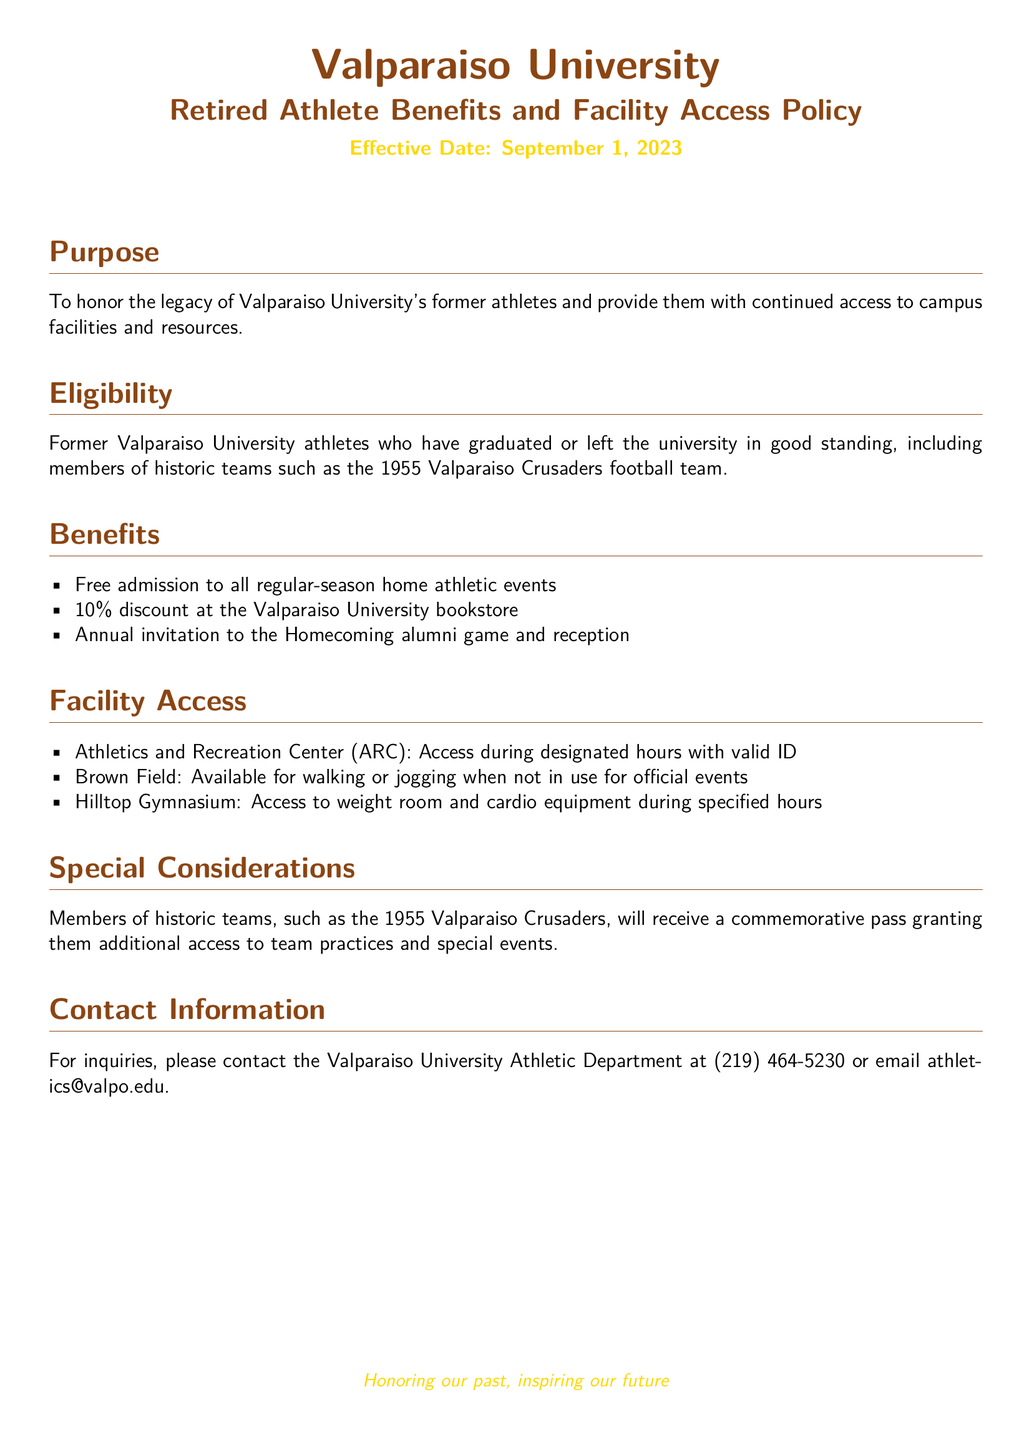What is the effective date of the policy? The effective date is stated in the document as September 1, 2023.
Answer: September 1, 2023 Who is eligible for the benefits? Eligibility includes former athletes who graduated or left in good standing, specifically those from historic teams like the 1955 Crusaders.
Answer: Former Valparaiso University athletes What type of discount do retired athletes receive at the university bookstore? The document specifies a 10% discount as one of the benefits for retired athletes.
Answer: 10% What is one of the benefits listed in the document? One of the benefits is free admission to all regular-season home athletic events.
Answer: Free admission to all regular-season home athletic events What access does the commemorative pass provide? The commemorative pass grants additional access to team practices and special events for members of historic teams.
Answer: Additional access to team practices and special events What is the main purpose of the policy? The document states that the purpose is to honor the legacy of former athletes and provide continued access to resources.
Answer: To honor the legacy of former athletes When can retired athletes access the Athletics and Recreation Center? They can access it during designated hours with a valid ID.
Answer: During designated hours with valid ID How can retired athletes contact the Athletic Department? The document provides contact details, including phone and email, for inquiries.
Answer: (219) 464-5230 or athletics@valpo.edu 